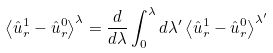<formula> <loc_0><loc_0><loc_500><loc_500>\left \langle \hat { u } ^ { 1 } _ { r } - \hat { u } ^ { 0 } _ { r } \right \rangle ^ { \lambda } & = \frac { d } { d \lambda } \int _ { 0 } ^ { \lambda } d \lambda ^ { \prime } \left \langle \hat { u } ^ { 1 } _ { r } - \hat { u } ^ { 0 } _ { r } \right \rangle ^ { \lambda ^ { \prime } }</formula> 